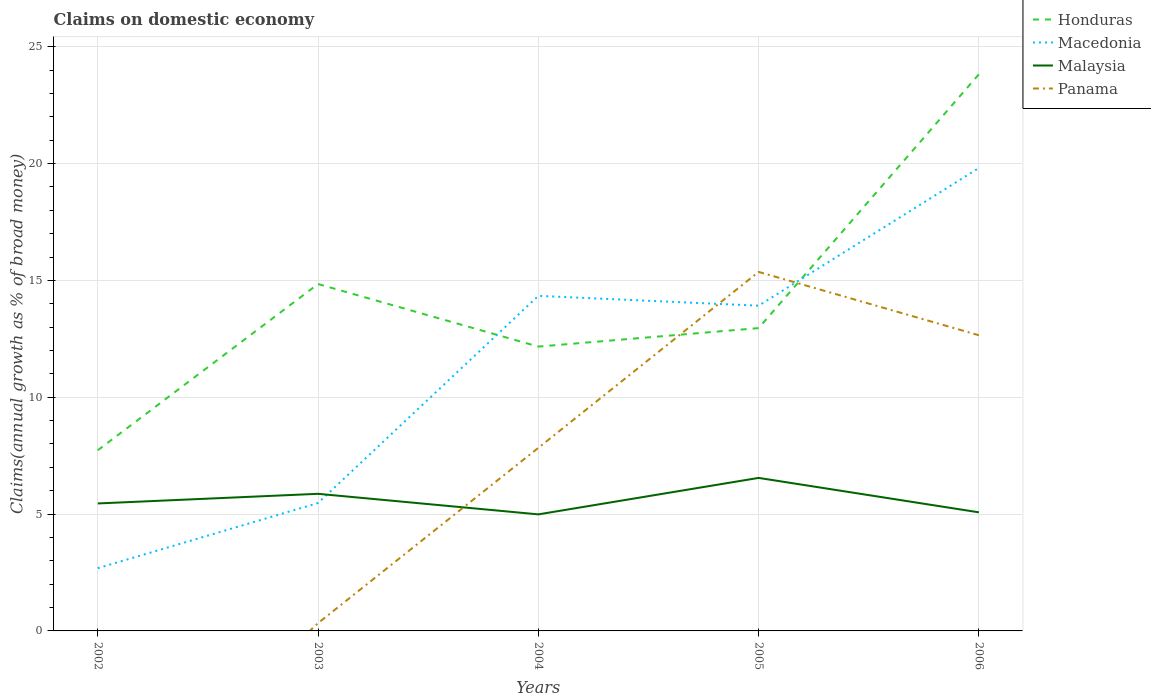Does the line corresponding to Malaysia intersect with the line corresponding to Honduras?
Your answer should be compact. No. Is the number of lines equal to the number of legend labels?
Your response must be concise. No. What is the total percentage of broad money claimed on domestic economy in Malaysia in the graph?
Ensure brevity in your answer.  -0.68. What is the difference between the highest and the second highest percentage of broad money claimed on domestic economy in Macedonia?
Keep it short and to the point. 17.12. Is the percentage of broad money claimed on domestic economy in Honduras strictly greater than the percentage of broad money claimed on domestic economy in Macedonia over the years?
Offer a very short reply. No. How many years are there in the graph?
Your answer should be compact. 5. What is the difference between two consecutive major ticks on the Y-axis?
Your answer should be very brief. 5. Are the values on the major ticks of Y-axis written in scientific E-notation?
Make the answer very short. No. Does the graph contain grids?
Offer a very short reply. Yes. Where does the legend appear in the graph?
Ensure brevity in your answer.  Top right. What is the title of the graph?
Provide a short and direct response. Claims on domestic economy. Does "Pakistan" appear as one of the legend labels in the graph?
Offer a very short reply. No. What is the label or title of the X-axis?
Ensure brevity in your answer.  Years. What is the label or title of the Y-axis?
Provide a short and direct response. Claims(annual growth as % of broad money). What is the Claims(annual growth as % of broad money) in Honduras in 2002?
Make the answer very short. 7.73. What is the Claims(annual growth as % of broad money) in Macedonia in 2002?
Offer a terse response. 2.68. What is the Claims(annual growth as % of broad money) in Malaysia in 2002?
Offer a terse response. 5.45. What is the Claims(annual growth as % of broad money) of Honduras in 2003?
Offer a terse response. 14.84. What is the Claims(annual growth as % of broad money) in Macedonia in 2003?
Give a very brief answer. 5.47. What is the Claims(annual growth as % of broad money) in Malaysia in 2003?
Ensure brevity in your answer.  5.87. What is the Claims(annual growth as % of broad money) of Panama in 2003?
Ensure brevity in your answer.  0.33. What is the Claims(annual growth as % of broad money) in Honduras in 2004?
Ensure brevity in your answer.  12.17. What is the Claims(annual growth as % of broad money) in Macedonia in 2004?
Offer a terse response. 14.34. What is the Claims(annual growth as % of broad money) of Malaysia in 2004?
Your answer should be compact. 4.99. What is the Claims(annual growth as % of broad money) of Panama in 2004?
Your answer should be very brief. 7.83. What is the Claims(annual growth as % of broad money) of Honduras in 2005?
Your response must be concise. 12.96. What is the Claims(annual growth as % of broad money) in Macedonia in 2005?
Give a very brief answer. 13.92. What is the Claims(annual growth as % of broad money) of Malaysia in 2005?
Your answer should be compact. 6.55. What is the Claims(annual growth as % of broad money) in Panama in 2005?
Give a very brief answer. 15.36. What is the Claims(annual growth as % of broad money) of Honduras in 2006?
Your response must be concise. 23.82. What is the Claims(annual growth as % of broad money) of Macedonia in 2006?
Ensure brevity in your answer.  19.81. What is the Claims(annual growth as % of broad money) in Malaysia in 2006?
Give a very brief answer. 5.07. What is the Claims(annual growth as % of broad money) in Panama in 2006?
Make the answer very short. 12.65. Across all years, what is the maximum Claims(annual growth as % of broad money) in Honduras?
Keep it short and to the point. 23.82. Across all years, what is the maximum Claims(annual growth as % of broad money) of Macedonia?
Provide a short and direct response. 19.81. Across all years, what is the maximum Claims(annual growth as % of broad money) in Malaysia?
Offer a terse response. 6.55. Across all years, what is the maximum Claims(annual growth as % of broad money) in Panama?
Your response must be concise. 15.36. Across all years, what is the minimum Claims(annual growth as % of broad money) in Honduras?
Your response must be concise. 7.73. Across all years, what is the minimum Claims(annual growth as % of broad money) of Macedonia?
Your answer should be compact. 2.68. Across all years, what is the minimum Claims(annual growth as % of broad money) in Malaysia?
Offer a very short reply. 4.99. Across all years, what is the minimum Claims(annual growth as % of broad money) of Panama?
Your response must be concise. 0. What is the total Claims(annual growth as % of broad money) of Honduras in the graph?
Make the answer very short. 71.52. What is the total Claims(annual growth as % of broad money) in Macedonia in the graph?
Ensure brevity in your answer.  56.22. What is the total Claims(annual growth as % of broad money) of Malaysia in the graph?
Ensure brevity in your answer.  27.93. What is the total Claims(annual growth as % of broad money) in Panama in the graph?
Give a very brief answer. 36.18. What is the difference between the Claims(annual growth as % of broad money) in Honduras in 2002 and that in 2003?
Your answer should be compact. -7.11. What is the difference between the Claims(annual growth as % of broad money) of Macedonia in 2002 and that in 2003?
Offer a terse response. -2.79. What is the difference between the Claims(annual growth as % of broad money) of Malaysia in 2002 and that in 2003?
Your answer should be compact. -0.41. What is the difference between the Claims(annual growth as % of broad money) in Honduras in 2002 and that in 2004?
Your response must be concise. -4.44. What is the difference between the Claims(annual growth as % of broad money) in Macedonia in 2002 and that in 2004?
Your answer should be very brief. -11.65. What is the difference between the Claims(annual growth as % of broad money) of Malaysia in 2002 and that in 2004?
Your answer should be compact. 0.47. What is the difference between the Claims(annual growth as % of broad money) of Honduras in 2002 and that in 2005?
Provide a short and direct response. -5.23. What is the difference between the Claims(annual growth as % of broad money) in Macedonia in 2002 and that in 2005?
Offer a very short reply. -11.23. What is the difference between the Claims(annual growth as % of broad money) in Malaysia in 2002 and that in 2005?
Your answer should be very brief. -1.09. What is the difference between the Claims(annual growth as % of broad money) in Honduras in 2002 and that in 2006?
Your answer should be very brief. -16.09. What is the difference between the Claims(annual growth as % of broad money) of Macedonia in 2002 and that in 2006?
Provide a short and direct response. -17.12. What is the difference between the Claims(annual growth as % of broad money) of Malaysia in 2002 and that in 2006?
Your response must be concise. 0.38. What is the difference between the Claims(annual growth as % of broad money) of Honduras in 2003 and that in 2004?
Provide a short and direct response. 2.68. What is the difference between the Claims(annual growth as % of broad money) of Macedonia in 2003 and that in 2004?
Ensure brevity in your answer.  -8.86. What is the difference between the Claims(annual growth as % of broad money) of Malaysia in 2003 and that in 2004?
Your answer should be compact. 0.88. What is the difference between the Claims(annual growth as % of broad money) in Panama in 2003 and that in 2004?
Provide a succinct answer. -7.5. What is the difference between the Claims(annual growth as % of broad money) of Honduras in 2003 and that in 2005?
Your answer should be very brief. 1.89. What is the difference between the Claims(annual growth as % of broad money) of Macedonia in 2003 and that in 2005?
Offer a terse response. -8.44. What is the difference between the Claims(annual growth as % of broad money) of Malaysia in 2003 and that in 2005?
Provide a succinct answer. -0.68. What is the difference between the Claims(annual growth as % of broad money) in Panama in 2003 and that in 2005?
Provide a succinct answer. -15.03. What is the difference between the Claims(annual growth as % of broad money) of Honduras in 2003 and that in 2006?
Offer a terse response. -8.98. What is the difference between the Claims(annual growth as % of broad money) in Macedonia in 2003 and that in 2006?
Offer a very short reply. -14.34. What is the difference between the Claims(annual growth as % of broad money) in Malaysia in 2003 and that in 2006?
Make the answer very short. 0.79. What is the difference between the Claims(annual growth as % of broad money) of Panama in 2003 and that in 2006?
Offer a terse response. -12.32. What is the difference between the Claims(annual growth as % of broad money) of Honduras in 2004 and that in 2005?
Provide a succinct answer. -0.79. What is the difference between the Claims(annual growth as % of broad money) in Macedonia in 2004 and that in 2005?
Offer a very short reply. 0.42. What is the difference between the Claims(annual growth as % of broad money) of Malaysia in 2004 and that in 2005?
Make the answer very short. -1.56. What is the difference between the Claims(annual growth as % of broad money) in Panama in 2004 and that in 2005?
Give a very brief answer. -7.53. What is the difference between the Claims(annual growth as % of broad money) of Honduras in 2004 and that in 2006?
Ensure brevity in your answer.  -11.65. What is the difference between the Claims(annual growth as % of broad money) in Macedonia in 2004 and that in 2006?
Your response must be concise. -5.47. What is the difference between the Claims(annual growth as % of broad money) in Malaysia in 2004 and that in 2006?
Offer a very short reply. -0.09. What is the difference between the Claims(annual growth as % of broad money) in Panama in 2004 and that in 2006?
Provide a short and direct response. -4.82. What is the difference between the Claims(annual growth as % of broad money) of Honduras in 2005 and that in 2006?
Offer a very short reply. -10.86. What is the difference between the Claims(annual growth as % of broad money) of Macedonia in 2005 and that in 2006?
Provide a short and direct response. -5.89. What is the difference between the Claims(annual growth as % of broad money) in Malaysia in 2005 and that in 2006?
Offer a terse response. 1.47. What is the difference between the Claims(annual growth as % of broad money) of Panama in 2005 and that in 2006?
Your answer should be compact. 2.71. What is the difference between the Claims(annual growth as % of broad money) of Honduras in 2002 and the Claims(annual growth as % of broad money) of Macedonia in 2003?
Ensure brevity in your answer.  2.26. What is the difference between the Claims(annual growth as % of broad money) of Honduras in 2002 and the Claims(annual growth as % of broad money) of Malaysia in 2003?
Ensure brevity in your answer.  1.86. What is the difference between the Claims(annual growth as % of broad money) in Honduras in 2002 and the Claims(annual growth as % of broad money) in Panama in 2003?
Offer a very short reply. 7.4. What is the difference between the Claims(annual growth as % of broad money) in Macedonia in 2002 and the Claims(annual growth as % of broad money) in Malaysia in 2003?
Offer a very short reply. -3.18. What is the difference between the Claims(annual growth as % of broad money) of Macedonia in 2002 and the Claims(annual growth as % of broad money) of Panama in 2003?
Offer a terse response. 2.35. What is the difference between the Claims(annual growth as % of broad money) in Malaysia in 2002 and the Claims(annual growth as % of broad money) in Panama in 2003?
Provide a succinct answer. 5.12. What is the difference between the Claims(annual growth as % of broad money) in Honduras in 2002 and the Claims(annual growth as % of broad money) in Macedonia in 2004?
Provide a short and direct response. -6.61. What is the difference between the Claims(annual growth as % of broad money) in Honduras in 2002 and the Claims(annual growth as % of broad money) in Malaysia in 2004?
Keep it short and to the point. 2.74. What is the difference between the Claims(annual growth as % of broad money) of Honduras in 2002 and the Claims(annual growth as % of broad money) of Panama in 2004?
Give a very brief answer. -0.1. What is the difference between the Claims(annual growth as % of broad money) of Macedonia in 2002 and the Claims(annual growth as % of broad money) of Malaysia in 2004?
Offer a terse response. -2.3. What is the difference between the Claims(annual growth as % of broad money) of Macedonia in 2002 and the Claims(annual growth as % of broad money) of Panama in 2004?
Offer a terse response. -5.15. What is the difference between the Claims(annual growth as % of broad money) in Malaysia in 2002 and the Claims(annual growth as % of broad money) in Panama in 2004?
Offer a terse response. -2.38. What is the difference between the Claims(annual growth as % of broad money) of Honduras in 2002 and the Claims(annual growth as % of broad money) of Macedonia in 2005?
Provide a succinct answer. -6.19. What is the difference between the Claims(annual growth as % of broad money) of Honduras in 2002 and the Claims(annual growth as % of broad money) of Malaysia in 2005?
Your response must be concise. 1.18. What is the difference between the Claims(annual growth as % of broad money) in Honduras in 2002 and the Claims(annual growth as % of broad money) in Panama in 2005?
Offer a terse response. -7.63. What is the difference between the Claims(annual growth as % of broad money) in Macedonia in 2002 and the Claims(annual growth as % of broad money) in Malaysia in 2005?
Keep it short and to the point. -3.86. What is the difference between the Claims(annual growth as % of broad money) in Macedonia in 2002 and the Claims(annual growth as % of broad money) in Panama in 2005?
Your answer should be compact. -12.68. What is the difference between the Claims(annual growth as % of broad money) of Malaysia in 2002 and the Claims(annual growth as % of broad money) of Panama in 2005?
Your answer should be very brief. -9.91. What is the difference between the Claims(annual growth as % of broad money) of Honduras in 2002 and the Claims(annual growth as % of broad money) of Macedonia in 2006?
Keep it short and to the point. -12.08. What is the difference between the Claims(annual growth as % of broad money) in Honduras in 2002 and the Claims(annual growth as % of broad money) in Malaysia in 2006?
Give a very brief answer. 2.66. What is the difference between the Claims(annual growth as % of broad money) of Honduras in 2002 and the Claims(annual growth as % of broad money) of Panama in 2006?
Offer a terse response. -4.92. What is the difference between the Claims(annual growth as % of broad money) of Macedonia in 2002 and the Claims(annual growth as % of broad money) of Malaysia in 2006?
Offer a very short reply. -2.39. What is the difference between the Claims(annual growth as % of broad money) in Macedonia in 2002 and the Claims(annual growth as % of broad money) in Panama in 2006?
Your answer should be compact. -9.97. What is the difference between the Claims(annual growth as % of broad money) in Malaysia in 2002 and the Claims(annual growth as % of broad money) in Panama in 2006?
Provide a succinct answer. -7.2. What is the difference between the Claims(annual growth as % of broad money) of Honduras in 2003 and the Claims(annual growth as % of broad money) of Macedonia in 2004?
Offer a very short reply. 0.51. What is the difference between the Claims(annual growth as % of broad money) in Honduras in 2003 and the Claims(annual growth as % of broad money) in Malaysia in 2004?
Your answer should be compact. 9.86. What is the difference between the Claims(annual growth as % of broad money) of Honduras in 2003 and the Claims(annual growth as % of broad money) of Panama in 2004?
Your answer should be compact. 7.01. What is the difference between the Claims(annual growth as % of broad money) of Macedonia in 2003 and the Claims(annual growth as % of broad money) of Malaysia in 2004?
Ensure brevity in your answer.  0.49. What is the difference between the Claims(annual growth as % of broad money) of Macedonia in 2003 and the Claims(annual growth as % of broad money) of Panama in 2004?
Keep it short and to the point. -2.36. What is the difference between the Claims(annual growth as % of broad money) in Malaysia in 2003 and the Claims(annual growth as % of broad money) in Panama in 2004?
Offer a terse response. -1.97. What is the difference between the Claims(annual growth as % of broad money) of Honduras in 2003 and the Claims(annual growth as % of broad money) of Macedonia in 2005?
Make the answer very short. 0.93. What is the difference between the Claims(annual growth as % of broad money) of Honduras in 2003 and the Claims(annual growth as % of broad money) of Malaysia in 2005?
Give a very brief answer. 8.3. What is the difference between the Claims(annual growth as % of broad money) in Honduras in 2003 and the Claims(annual growth as % of broad money) in Panama in 2005?
Provide a succinct answer. -0.52. What is the difference between the Claims(annual growth as % of broad money) of Macedonia in 2003 and the Claims(annual growth as % of broad money) of Malaysia in 2005?
Make the answer very short. -1.07. What is the difference between the Claims(annual growth as % of broad money) in Macedonia in 2003 and the Claims(annual growth as % of broad money) in Panama in 2005?
Provide a short and direct response. -9.89. What is the difference between the Claims(annual growth as % of broad money) of Malaysia in 2003 and the Claims(annual growth as % of broad money) of Panama in 2005?
Make the answer very short. -9.5. What is the difference between the Claims(annual growth as % of broad money) of Honduras in 2003 and the Claims(annual growth as % of broad money) of Macedonia in 2006?
Give a very brief answer. -4.96. What is the difference between the Claims(annual growth as % of broad money) in Honduras in 2003 and the Claims(annual growth as % of broad money) in Malaysia in 2006?
Offer a very short reply. 9.77. What is the difference between the Claims(annual growth as % of broad money) of Honduras in 2003 and the Claims(annual growth as % of broad money) of Panama in 2006?
Offer a very short reply. 2.19. What is the difference between the Claims(annual growth as % of broad money) in Macedonia in 2003 and the Claims(annual growth as % of broad money) in Malaysia in 2006?
Your answer should be very brief. 0.4. What is the difference between the Claims(annual growth as % of broad money) in Macedonia in 2003 and the Claims(annual growth as % of broad money) in Panama in 2006?
Offer a terse response. -7.18. What is the difference between the Claims(annual growth as % of broad money) of Malaysia in 2003 and the Claims(annual growth as % of broad money) of Panama in 2006?
Offer a terse response. -6.79. What is the difference between the Claims(annual growth as % of broad money) in Honduras in 2004 and the Claims(annual growth as % of broad money) in Macedonia in 2005?
Your answer should be compact. -1.75. What is the difference between the Claims(annual growth as % of broad money) of Honduras in 2004 and the Claims(annual growth as % of broad money) of Malaysia in 2005?
Offer a very short reply. 5.62. What is the difference between the Claims(annual growth as % of broad money) in Honduras in 2004 and the Claims(annual growth as % of broad money) in Panama in 2005?
Offer a very short reply. -3.2. What is the difference between the Claims(annual growth as % of broad money) of Macedonia in 2004 and the Claims(annual growth as % of broad money) of Malaysia in 2005?
Your answer should be very brief. 7.79. What is the difference between the Claims(annual growth as % of broad money) of Macedonia in 2004 and the Claims(annual growth as % of broad money) of Panama in 2005?
Give a very brief answer. -1.02. What is the difference between the Claims(annual growth as % of broad money) in Malaysia in 2004 and the Claims(annual growth as % of broad money) in Panama in 2005?
Provide a short and direct response. -10.38. What is the difference between the Claims(annual growth as % of broad money) of Honduras in 2004 and the Claims(annual growth as % of broad money) of Macedonia in 2006?
Give a very brief answer. -7.64. What is the difference between the Claims(annual growth as % of broad money) of Honduras in 2004 and the Claims(annual growth as % of broad money) of Malaysia in 2006?
Provide a succinct answer. 7.09. What is the difference between the Claims(annual growth as % of broad money) of Honduras in 2004 and the Claims(annual growth as % of broad money) of Panama in 2006?
Keep it short and to the point. -0.49. What is the difference between the Claims(annual growth as % of broad money) of Macedonia in 2004 and the Claims(annual growth as % of broad money) of Malaysia in 2006?
Give a very brief answer. 9.26. What is the difference between the Claims(annual growth as % of broad money) in Macedonia in 2004 and the Claims(annual growth as % of broad money) in Panama in 2006?
Your answer should be compact. 1.69. What is the difference between the Claims(annual growth as % of broad money) in Malaysia in 2004 and the Claims(annual growth as % of broad money) in Panama in 2006?
Ensure brevity in your answer.  -7.66. What is the difference between the Claims(annual growth as % of broad money) of Honduras in 2005 and the Claims(annual growth as % of broad money) of Macedonia in 2006?
Make the answer very short. -6.85. What is the difference between the Claims(annual growth as % of broad money) of Honduras in 2005 and the Claims(annual growth as % of broad money) of Malaysia in 2006?
Provide a succinct answer. 7.88. What is the difference between the Claims(annual growth as % of broad money) of Honduras in 2005 and the Claims(annual growth as % of broad money) of Panama in 2006?
Make the answer very short. 0.31. What is the difference between the Claims(annual growth as % of broad money) of Macedonia in 2005 and the Claims(annual growth as % of broad money) of Malaysia in 2006?
Offer a very short reply. 8.84. What is the difference between the Claims(annual growth as % of broad money) in Macedonia in 2005 and the Claims(annual growth as % of broad money) in Panama in 2006?
Give a very brief answer. 1.27. What is the difference between the Claims(annual growth as % of broad money) of Malaysia in 2005 and the Claims(annual growth as % of broad money) of Panama in 2006?
Your answer should be very brief. -6.1. What is the average Claims(annual growth as % of broad money) of Honduras per year?
Your answer should be very brief. 14.3. What is the average Claims(annual growth as % of broad money) in Macedonia per year?
Your answer should be compact. 11.24. What is the average Claims(annual growth as % of broad money) of Malaysia per year?
Give a very brief answer. 5.59. What is the average Claims(annual growth as % of broad money) of Panama per year?
Your answer should be compact. 7.24. In the year 2002, what is the difference between the Claims(annual growth as % of broad money) in Honduras and Claims(annual growth as % of broad money) in Macedonia?
Make the answer very short. 5.05. In the year 2002, what is the difference between the Claims(annual growth as % of broad money) of Honduras and Claims(annual growth as % of broad money) of Malaysia?
Make the answer very short. 2.28. In the year 2002, what is the difference between the Claims(annual growth as % of broad money) of Macedonia and Claims(annual growth as % of broad money) of Malaysia?
Provide a short and direct response. -2.77. In the year 2003, what is the difference between the Claims(annual growth as % of broad money) of Honduras and Claims(annual growth as % of broad money) of Macedonia?
Offer a very short reply. 9.37. In the year 2003, what is the difference between the Claims(annual growth as % of broad money) in Honduras and Claims(annual growth as % of broad money) in Malaysia?
Offer a very short reply. 8.98. In the year 2003, what is the difference between the Claims(annual growth as % of broad money) of Honduras and Claims(annual growth as % of broad money) of Panama?
Give a very brief answer. 14.51. In the year 2003, what is the difference between the Claims(annual growth as % of broad money) of Macedonia and Claims(annual growth as % of broad money) of Malaysia?
Your answer should be compact. -0.39. In the year 2003, what is the difference between the Claims(annual growth as % of broad money) in Macedonia and Claims(annual growth as % of broad money) in Panama?
Offer a terse response. 5.14. In the year 2003, what is the difference between the Claims(annual growth as % of broad money) in Malaysia and Claims(annual growth as % of broad money) in Panama?
Provide a succinct answer. 5.53. In the year 2004, what is the difference between the Claims(annual growth as % of broad money) of Honduras and Claims(annual growth as % of broad money) of Macedonia?
Ensure brevity in your answer.  -2.17. In the year 2004, what is the difference between the Claims(annual growth as % of broad money) of Honduras and Claims(annual growth as % of broad money) of Malaysia?
Give a very brief answer. 7.18. In the year 2004, what is the difference between the Claims(annual growth as % of broad money) in Honduras and Claims(annual growth as % of broad money) in Panama?
Your answer should be compact. 4.33. In the year 2004, what is the difference between the Claims(annual growth as % of broad money) in Macedonia and Claims(annual growth as % of broad money) in Malaysia?
Provide a short and direct response. 9.35. In the year 2004, what is the difference between the Claims(annual growth as % of broad money) in Macedonia and Claims(annual growth as % of broad money) in Panama?
Give a very brief answer. 6.5. In the year 2004, what is the difference between the Claims(annual growth as % of broad money) in Malaysia and Claims(annual growth as % of broad money) in Panama?
Ensure brevity in your answer.  -2.85. In the year 2005, what is the difference between the Claims(annual growth as % of broad money) of Honduras and Claims(annual growth as % of broad money) of Macedonia?
Keep it short and to the point. -0.96. In the year 2005, what is the difference between the Claims(annual growth as % of broad money) in Honduras and Claims(annual growth as % of broad money) in Malaysia?
Give a very brief answer. 6.41. In the year 2005, what is the difference between the Claims(annual growth as % of broad money) of Honduras and Claims(annual growth as % of broad money) of Panama?
Provide a short and direct response. -2.4. In the year 2005, what is the difference between the Claims(annual growth as % of broad money) of Macedonia and Claims(annual growth as % of broad money) of Malaysia?
Provide a short and direct response. 7.37. In the year 2005, what is the difference between the Claims(annual growth as % of broad money) in Macedonia and Claims(annual growth as % of broad money) in Panama?
Give a very brief answer. -1.45. In the year 2005, what is the difference between the Claims(annual growth as % of broad money) in Malaysia and Claims(annual growth as % of broad money) in Panama?
Provide a succinct answer. -8.81. In the year 2006, what is the difference between the Claims(annual growth as % of broad money) in Honduras and Claims(annual growth as % of broad money) in Macedonia?
Provide a short and direct response. 4.01. In the year 2006, what is the difference between the Claims(annual growth as % of broad money) in Honduras and Claims(annual growth as % of broad money) in Malaysia?
Your answer should be very brief. 18.75. In the year 2006, what is the difference between the Claims(annual growth as % of broad money) in Honduras and Claims(annual growth as % of broad money) in Panama?
Give a very brief answer. 11.17. In the year 2006, what is the difference between the Claims(annual growth as % of broad money) in Macedonia and Claims(annual growth as % of broad money) in Malaysia?
Your answer should be compact. 14.73. In the year 2006, what is the difference between the Claims(annual growth as % of broad money) of Macedonia and Claims(annual growth as % of broad money) of Panama?
Provide a short and direct response. 7.16. In the year 2006, what is the difference between the Claims(annual growth as % of broad money) of Malaysia and Claims(annual growth as % of broad money) of Panama?
Make the answer very short. -7.58. What is the ratio of the Claims(annual growth as % of broad money) of Honduras in 2002 to that in 2003?
Provide a succinct answer. 0.52. What is the ratio of the Claims(annual growth as % of broad money) of Macedonia in 2002 to that in 2003?
Provide a short and direct response. 0.49. What is the ratio of the Claims(annual growth as % of broad money) in Malaysia in 2002 to that in 2003?
Keep it short and to the point. 0.93. What is the ratio of the Claims(annual growth as % of broad money) in Honduras in 2002 to that in 2004?
Your answer should be compact. 0.64. What is the ratio of the Claims(annual growth as % of broad money) of Macedonia in 2002 to that in 2004?
Offer a very short reply. 0.19. What is the ratio of the Claims(annual growth as % of broad money) of Malaysia in 2002 to that in 2004?
Offer a terse response. 1.09. What is the ratio of the Claims(annual growth as % of broad money) of Honduras in 2002 to that in 2005?
Make the answer very short. 0.6. What is the ratio of the Claims(annual growth as % of broad money) in Macedonia in 2002 to that in 2005?
Provide a succinct answer. 0.19. What is the ratio of the Claims(annual growth as % of broad money) of Malaysia in 2002 to that in 2005?
Your answer should be very brief. 0.83. What is the ratio of the Claims(annual growth as % of broad money) of Honduras in 2002 to that in 2006?
Make the answer very short. 0.32. What is the ratio of the Claims(annual growth as % of broad money) of Macedonia in 2002 to that in 2006?
Offer a very short reply. 0.14. What is the ratio of the Claims(annual growth as % of broad money) in Malaysia in 2002 to that in 2006?
Your response must be concise. 1.07. What is the ratio of the Claims(annual growth as % of broad money) of Honduras in 2003 to that in 2004?
Keep it short and to the point. 1.22. What is the ratio of the Claims(annual growth as % of broad money) of Macedonia in 2003 to that in 2004?
Provide a short and direct response. 0.38. What is the ratio of the Claims(annual growth as % of broad money) of Malaysia in 2003 to that in 2004?
Your response must be concise. 1.18. What is the ratio of the Claims(annual growth as % of broad money) of Panama in 2003 to that in 2004?
Provide a short and direct response. 0.04. What is the ratio of the Claims(annual growth as % of broad money) of Honduras in 2003 to that in 2005?
Keep it short and to the point. 1.15. What is the ratio of the Claims(annual growth as % of broad money) of Macedonia in 2003 to that in 2005?
Provide a short and direct response. 0.39. What is the ratio of the Claims(annual growth as % of broad money) in Malaysia in 2003 to that in 2005?
Give a very brief answer. 0.9. What is the ratio of the Claims(annual growth as % of broad money) of Panama in 2003 to that in 2005?
Provide a short and direct response. 0.02. What is the ratio of the Claims(annual growth as % of broad money) in Honduras in 2003 to that in 2006?
Offer a very short reply. 0.62. What is the ratio of the Claims(annual growth as % of broad money) of Macedonia in 2003 to that in 2006?
Make the answer very short. 0.28. What is the ratio of the Claims(annual growth as % of broad money) of Malaysia in 2003 to that in 2006?
Offer a terse response. 1.16. What is the ratio of the Claims(annual growth as % of broad money) in Panama in 2003 to that in 2006?
Provide a succinct answer. 0.03. What is the ratio of the Claims(annual growth as % of broad money) of Honduras in 2004 to that in 2005?
Your response must be concise. 0.94. What is the ratio of the Claims(annual growth as % of broad money) of Macedonia in 2004 to that in 2005?
Make the answer very short. 1.03. What is the ratio of the Claims(annual growth as % of broad money) of Malaysia in 2004 to that in 2005?
Provide a short and direct response. 0.76. What is the ratio of the Claims(annual growth as % of broad money) of Panama in 2004 to that in 2005?
Your response must be concise. 0.51. What is the ratio of the Claims(annual growth as % of broad money) in Honduras in 2004 to that in 2006?
Provide a short and direct response. 0.51. What is the ratio of the Claims(annual growth as % of broad money) in Macedonia in 2004 to that in 2006?
Provide a short and direct response. 0.72. What is the ratio of the Claims(annual growth as % of broad money) of Malaysia in 2004 to that in 2006?
Your response must be concise. 0.98. What is the ratio of the Claims(annual growth as % of broad money) of Panama in 2004 to that in 2006?
Your answer should be very brief. 0.62. What is the ratio of the Claims(annual growth as % of broad money) of Honduras in 2005 to that in 2006?
Give a very brief answer. 0.54. What is the ratio of the Claims(annual growth as % of broad money) of Macedonia in 2005 to that in 2006?
Keep it short and to the point. 0.7. What is the ratio of the Claims(annual growth as % of broad money) in Malaysia in 2005 to that in 2006?
Provide a short and direct response. 1.29. What is the ratio of the Claims(annual growth as % of broad money) in Panama in 2005 to that in 2006?
Offer a terse response. 1.21. What is the difference between the highest and the second highest Claims(annual growth as % of broad money) in Honduras?
Ensure brevity in your answer.  8.98. What is the difference between the highest and the second highest Claims(annual growth as % of broad money) of Macedonia?
Your response must be concise. 5.47. What is the difference between the highest and the second highest Claims(annual growth as % of broad money) of Malaysia?
Offer a very short reply. 0.68. What is the difference between the highest and the second highest Claims(annual growth as % of broad money) in Panama?
Provide a succinct answer. 2.71. What is the difference between the highest and the lowest Claims(annual growth as % of broad money) in Honduras?
Your answer should be very brief. 16.09. What is the difference between the highest and the lowest Claims(annual growth as % of broad money) of Macedonia?
Your answer should be very brief. 17.12. What is the difference between the highest and the lowest Claims(annual growth as % of broad money) of Malaysia?
Your answer should be compact. 1.56. What is the difference between the highest and the lowest Claims(annual growth as % of broad money) of Panama?
Ensure brevity in your answer.  15.36. 